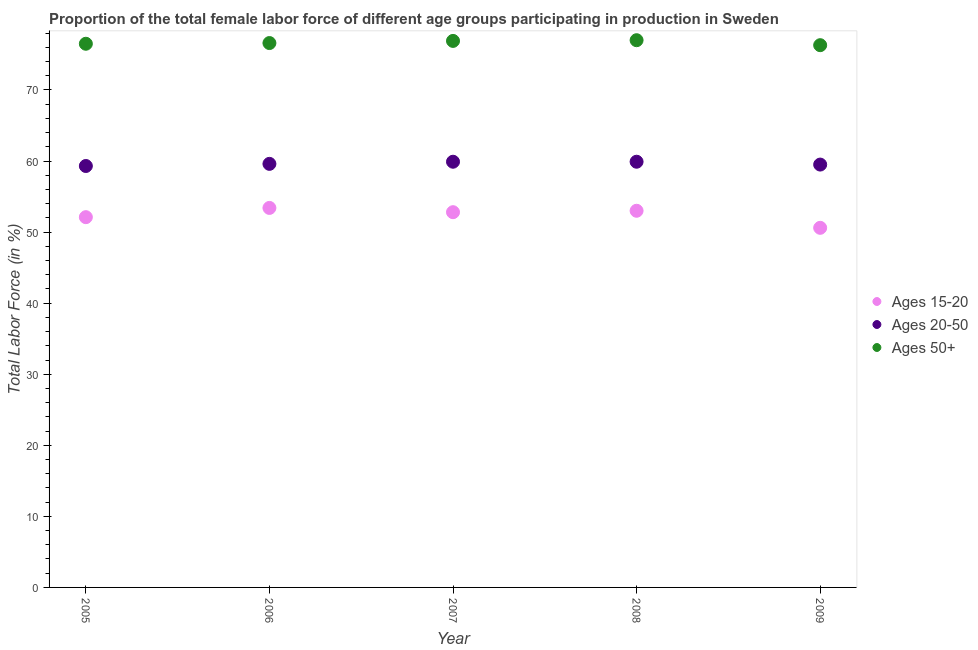How many different coloured dotlines are there?
Make the answer very short. 3. What is the percentage of female labor force above age 50 in 2006?
Ensure brevity in your answer.  76.6. Across all years, what is the maximum percentage of female labor force above age 50?
Offer a terse response. 77. Across all years, what is the minimum percentage of female labor force within the age group 20-50?
Give a very brief answer. 59.3. In which year was the percentage of female labor force above age 50 minimum?
Ensure brevity in your answer.  2009. What is the total percentage of female labor force within the age group 20-50 in the graph?
Offer a terse response. 298.2. What is the difference between the percentage of female labor force within the age group 20-50 in 2008 and that in 2009?
Your response must be concise. 0.4. What is the difference between the percentage of female labor force above age 50 in 2006 and the percentage of female labor force within the age group 15-20 in 2005?
Your response must be concise. 24.5. What is the average percentage of female labor force within the age group 20-50 per year?
Your answer should be very brief. 59.64. In the year 2006, what is the difference between the percentage of female labor force above age 50 and percentage of female labor force within the age group 20-50?
Your answer should be compact. 17. What is the ratio of the percentage of female labor force within the age group 15-20 in 2007 to that in 2008?
Your response must be concise. 1. What is the difference between the highest and the second highest percentage of female labor force within the age group 15-20?
Ensure brevity in your answer.  0.4. What is the difference between the highest and the lowest percentage of female labor force above age 50?
Give a very brief answer. 0.7. In how many years, is the percentage of female labor force within the age group 20-50 greater than the average percentage of female labor force within the age group 20-50 taken over all years?
Ensure brevity in your answer.  2. Is the sum of the percentage of female labor force within the age group 20-50 in 2008 and 2009 greater than the maximum percentage of female labor force above age 50 across all years?
Ensure brevity in your answer.  Yes. Is it the case that in every year, the sum of the percentage of female labor force within the age group 15-20 and percentage of female labor force within the age group 20-50 is greater than the percentage of female labor force above age 50?
Your answer should be very brief. Yes. Does the percentage of female labor force above age 50 monotonically increase over the years?
Provide a short and direct response. No. Is the percentage of female labor force within the age group 15-20 strictly greater than the percentage of female labor force within the age group 20-50 over the years?
Provide a short and direct response. No. Is the percentage of female labor force within the age group 15-20 strictly less than the percentage of female labor force above age 50 over the years?
Give a very brief answer. Yes. How many dotlines are there?
Provide a succinct answer. 3. How many years are there in the graph?
Make the answer very short. 5. What is the difference between two consecutive major ticks on the Y-axis?
Offer a very short reply. 10. Are the values on the major ticks of Y-axis written in scientific E-notation?
Your answer should be compact. No. Does the graph contain any zero values?
Keep it short and to the point. No. Does the graph contain grids?
Provide a short and direct response. No. How are the legend labels stacked?
Offer a very short reply. Vertical. What is the title of the graph?
Offer a terse response. Proportion of the total female labor force of different age groups participating in production in Sweden. Does "Taxes" appear as one of the legend labels in the graph?
Give a very brief answer. No. What is the label or title of the X-axis?
Offer a terse response. Year. What is the label or title of the Y-axis?
Ensure brevity in your answer.  Total Labor Force (in %). What is the Total Labor Force (in %) of Ages 15-20 in 2005?
Your answer should be compact. 52.1. What is the Total Labor Force (in %) of Ages 20-50 in 2005?
Make the answer very short. 59.3. What is the Total Labor Force (in %) of Ages 50+ in 2005?
Give a very brief answer. 76.5. What is the Total Labor Force (in %) in Ages 15-20 in 2006?
Your answer should be very brief. 53.4. What is the Total Labor Force (in %) of Ages 20-50 in 2006?
Offer a terse response. 59.6. What is the Total Labor Force (in %) of Ages 50+ in 2006?
Give a very brief answer. 76.6. What is the Total Labor Force (in %) in Ages 15-20 in 2007?
Provide a short and direct response. 52.8. What is the Total Labor Force (in %) of Ages 20-50 in 2007?
Offer a very short reply. 59.9. What is the Total Labor Force (in %) of Ages 50+ in 2007?
Make the answer very short. 76.9. What is the Total Labor Force (in %) in Ages 15-20 in 2008?
Keep it short and to the point. 53. What is the Total Labor Force (in %) of Ages 20-50 in 2008?
Offer a terse response. 59.9. What is the Total Labor Force (in %) of Ages 15-20 in 2009?
Make the answer very short. 50.6. What is the Total Labor Force (in %) in Ages 20-50 in 2009?
Make the answer very short. 59.5. What is the Total Labor Force (in %) in Ages 50+ in 2009?
Provide a succinct answer. 76.3. Across all years, what is the maximum Total Labor Force (in %) of Ages 15-20?
Provide a short and direct response. 53.4. Across all years, what is the maximum Total Labor Force (in %) of Ages 20-50?
Keep it short and to the point. 59.9. Across all years, what is the minimum Total Labor Force (in %) in Ages 15-20?
Your answer should be compact. 50.6. Across all years, what is the minimum Total Labor Force (in %) of Ages 20-50?
Your answer should be compact. 59.3. Across all years, what is the minimum Total Labor Force (in %) of Ages 50+?
Provide a succinct answer. 76.3. What is the total Total Labor Force (in %) in Ages 15-20 in the graph?
Offer a terse response. 261.9. What is the total Total Labor Force (in %) in Ages 20-50 in the graph?
Keep it short and to the point. 298.2. What is the total Total Labor Force (in %) of Ages 50+ in the graph?
Provide a short and direct response. 383.3. What is the difference between the Total Labor Force (in %) in Ages 15-20 in 2005 and that in 2006?
Provide a succinct answer. -1.3. What is the difference between the Total Labor Force (in %) in Ages 50+ in 2005 and that in 2006?
Provide a short and direct response. -0.1. What is the difference between the Total Labor Force (in %) of Ages 15-20 in 2005 and that in 2008?
Offer a very short reply. -0.9. What is the difference between the Total Labor Force (in %) of Ages 20-50 in 2005 and that in 2008?
Your answer should be compact. -0.6. What is the difference between the Total Labor Force (in %) of Ages 15-20 in 2005 and that in 2009?
Provide a short and direct response. 1.5. What is the difference between the Total Labor Force (in %) of Ages 20-50 in 2005 and that in 2009?
Your response must be concise. -0.2. What is the difference between the Total Labor Force (in %) in Ages 20-50 in 2006 and that in 2007?
Provide a succinct answer. -0.3. What is the difference between the Total Labor Force (in %) in Ages 50+ in 2006 and that in 2007?
Ensure brevity in your answer.  -0.3. What is the difference between the Total Labor Force (in %) of Ages 15-20 in 2006 and that in 2008?
Ensure brevity in your answer.  0.4. What is the difference between the Total Labor Force (in %) in Ages 50+ in 2006 and that in 2009?
Ensure brevity in your answer.  0.3. What is the difference between the Total Labor Force (in %) of Ages 15-20 in 2007 and that in 2008?
Your answer should be very brief. -0.2. What is the difference between the Total Labor Force (in %) of Ages 20-50 in 2007 and that in 2008?
Offer a terse response. 0. What is the difference between the Total Labor Force (in %) in Ages 50+ in 2007 and that in 2008?
Make the answer very short. -0.1. What is the difference between the Total Labor Force (in %) in Ages 20-50 in 2007 and that in 2009?
Your answer should be compact. 0.4. What is the difference between the Total Labor Force (in %) in Ages 50+ in 2007 and that in 2009?
Give a very brief answer. 0.6. What is the difference between the Total Labor Force (in %) of Ages 50+ in 2008 and that in 2009?
Give a very brief answer. 0.7. What is the difference between the Total Labor Force (in %) of Ages 15-20 in 2005 and the Total Labor Force (in %) of Ages 20-50 in 2006?
Give a very brief answer. -7.5. What is the difference between the Total Labor Force (in %) of Ages 15-20 in 2005 and the Total Labor Force (in %) of Ages 50+ in 2006?
Make the answer very short. -24.5. What is the difference between the Total Labor Force (in %) of Ages 20-50 in 2005 and the Total Labor Force (in %) of Ages 50+ in 2006?
Your answer should be compact. -17.3. What is the difference between the Total Labor Force (in %) in Ages 15-20 in 2005 and the Total Labor Force (in %) in Ages 50+ in 2007?
Your answer should be very brief. -24.8. What is the difference between the Total Labor Force (in %) in Ages 20-50 in 2005 and the Total Labor Force (in %) in Ages 50+ in 2007?
Your response must be concise. -17.6. What is the difference between the Total Labor Force (in %) of Ages 15-20 in 2005 and the Total Labor Force (in %) of Ages 50+ in 2008?
Offer a very short reply. -24.9. What is the difference between the Total Labor Force (in %) of Ages 20-50 in 2005 and the Total Labor Force (in %) of Ages 50+ in 2008?
Offer a very short reply. -17.7. What is the difference between the Total Labor Force (in %) of Ages 15-20 in 2005 and the Total Labor Force (in %) of Ages 20-50 in 2009?
Give a very brief answer. -7.4. What is the difference between the Total Labor Force (in %) of Ages 15-20 in 2005 and the Total Labor Force (in %) of Ages 50+ in 2009?
Make the answer very short. -24.2. What is the difference between the Total Labor Force (in %) in Ages 15-20 in 2006 and the Total Labor Force (in %) in Ages 20-50 in 2007?
Offer a very short reply. -6.5. What is the difference between the Total Labor Force (in %) in Ages 15-20 in 2006 and the Total Labor Force (in %) in Ages 50+ in 2007?
Your answer should be compact. -23.5. What is the difference between the Total Labor Force (in %) in Ages 20-50 in 2006 and the Total Labor Force (in %) in Ages 50+ in 2007?
Your response must be concise. -17.3. What is the difference between the Total Labor Force (in %) in Ages 15-20 in 2006 and the Total Labor Force (in %) in Ages 50+ in 2008?
Provide a succinct answer. -23.6. What is the difference between the Total Labor Force (in %) of Ages 20-50 in 2006 and the Total Labor Force (in %) of Ages 50+ in 2008?
Your answer should be compact. -17.4. What is the difference between the Total Labor Force (in %) in Ages 15-20 in 2006 and the Total Labor Force (in %) in Ages 20-50 in 2009?
Provide a succinct answer. -6.1. What is the difference between the Total Labor Force (in %) of Ages 15-20 in 2006 and the Total Labor Force (in %) of Ages 50+ in 2009?
Your response must be concise. -22.9. What is the difference between the Total Labor Force (in %) of Ages 20-50 in 2006 and the Total Labor Force (in %) of Ages 50+ in 2009?
Your answer should be compact. -16.7. What is the difference between the Total Labor Force (in %) in Ages 15-20 in 2007 and the Total Labor Force (in %) in Ages 20-50 in 2008?
Give a very brief answer. -7.1. What is the difference between the Total Labor Force (in %) in Ages 15-20 in 2007 and the Total Labor Force (in %) in Ages 50+ in 2008?
Offer a terse response. -24.2. What is the difference between the Total Labor Force (in %) of Ages 20-50 in 2007 and the Total Labor Force (in %) of Ages 50+ in 2008?
Ensure brevity in your answer.  -17.1. What is the difference between the Total Labor Force (in %) of Ages 15-20 in 2007 and the Total Labor Force (in %) of Ages 50+ in 2009?
Your response must be concise. -23.5. What is the difference between the Total Labor Force (in %) in Ages 20-50 in 2007 and the Total Labor Force (in %) in Ages 50+ in 2009?
Your answer should be very brief. -16.4. What is the difference between the Total Labor Force (in %) of Ages 15-20 in 2008 and the Total Labor Force (in %) of Ages 20-50 in 2009?
Your response must be concise. -6.5. What is the difference between the Total Labor Force (in %) in Ages 15-20 in 2008 and the Total Labor Force (in %) in Ages 50+ in 2009?
Your response must be concise. -23.3. What is the difference between the Total Labor Force (in %) in Ages 20-50 in 2008 and the Total Labor Force (in %) in Ages 50+ in 2009?
Your answer should be very brief. -16.4. What is the average Total Labor Force (in %) of Ages 15-20 per year?
Keep it short and to the point. 52.38. What is the average Total Labor Force (in %) of Ages 20-50 per year?
Give a very brief answer. 59.64. What is the average Total Labor Force (in %) of Ages 50+ per year?
Offer a very short reply. 76.66. In the year 2005, what is the difference between the Total Labor Force (in %) in Ages 15-20 and Total Labor Force (in %) in Ages 50+?
Provide a short and direct response. -24.4. In the year 2005, what is the difference between the Total Labor Force (in %) of Ages 20-50 and Total Labor Force (in %) of Ages 50+?
Offer a very short reply. -17.2. In the year 2006, what is the difference between the Total Labor Force (in %) of Ages 15-20 and Total Labor Force (in %) of Ages 20-50?
Your answer should be compact. -6.2. In the year 2006, what is the difference between the Total Labor Force (in %) of Ages 15-20 and Total Labor Force (in %) of Ages 50+?
Keep it short and to the point. -23.2. In the year 2007, what is the difference between the Total Labor Force (in %) in Ages 15-20 and Total Labor Force (in %) in Ages 50+?
Offer a very short reply. -24.1. In the year 2008, what is the difference between the Total Labor Force (in %) in Ages 15-20 and Total Labor Force (in %) in Ages 20-50?
Provide a succinct answer. -6.9. In the year 2008, what is the difference between the Total Labor Force (in %) of Ages 15-20 and Total Labor Force (in %) of Ages 50+?
Your response must be concise. -24. In the year 2008, what is the difference between the Total Labor Force (in %) in Ages 20-50 and Total Labor Force (in %) in Ages 50+?
Your answer should be compact. -17.1. In the year 2009, what is the difference between the Total Labor Force (in %) in Ages 15-20 and Total Labor Force (in %) in Ages 20-50?
Your answer should be compact. -8.9. In the year 2009, what is the difference between the Total Labor Force (in %) of Ages 15-20 and Total Labor Force (in %) of Ages 50+?
Provide a succinct answer. -25.7. In the year 2009, what is the difference between the Total Labor Force (in %) of Ages 20-50 and Total Labor Force (in %) of Ages 50+?
Your answer should be very brief. -16.8. What is the ratio of the Total Labor Force (in %) in Ages 15-20 in 2005 to that in 2006?
Your answer should be compact. 0.98. What is the ratio of the Total Labor Force (in %) of Ages 20-50 in 2005 to that in 2006?
Make the answer very short. 0.99. What is the ratio of the Total Labor Force (in %) of Ages 50+ in 2005 to that in 2006?
Provide a succinct answer. 1. What is the ratio of the Total Labor Force (in %) in Ages 15-20 in 2005 to that in 2007?
Keep it short and to the point. 0.99. What is the ratio of the Total Labor Force (in %) in Ages 50+ in 2005 to that in 2008?
Provide a short and direct response. 0.99. What is the ratio of the Total Labor Force (in %) in Ages 15-20 in 2005 to that in 2009?
Make the answer very short. 1.03. What is the ratio of the Total Labor Force (in %) in Ages 20-50 in 2005 to that in 2009?
Ensure brevity in your answer.  1. What is the ratio of the Total Labor Force (in %) in Ages 50+ in 2005 to that in 2009?
Offer a terse response. 1. What is the ratio of the Total Labor Force (in %) of Ages 15-20 in 2006 to that in 2007?
Provide a short and direct response. 1.01. What is the ratio of the Total Labor Force (in %) of Ages 20-50 in 2006 to that in 2007?
Provide a short and direct response. 0.99. What is the ratio of the Total Labor Force (in %) of Ages 15-20 in 2006 to that in 2008?
Keep it short and to the point. 1.01. What is the ratio of the Total Labor Force (in %) in Ages 20-50 in 2006 to that in 2008?
Ensure brevity in your answer.  0.99. What is the ratio of the Total Labor Force (in %) of Ages 50+ in 2006 to that in 2008?
Make the answer very short. 0.99. What is the ratio of the Total Labor Force (in %) of Ages 15-20 in 2006 to that in 2009?
Provide a short and direct response. 1.06. What is the ratio of the Total Labor Force (in %) of Ages 20-50 in 2006 to that in 2009?
Offer a terse response. 1. What is the ratio of the Total Labor Force (in %) of Ages 15-20 in 2007 to that in 2008?
Offer a terse response. 1. What is the ratio of the Total Labor Force (in %) of Ages 20-50 in 2007 to that in 2008?
Your answer should be very brief. 1. What is the ratio of the Total Labor Force (in %) in Ages 50+ in 2007 to that in 2008?
Provide a succinct answer. 1. What is the ratio of the Total Labor Force (in %) of Ages 15-20 in 2007 to that in 2009?
Provide a short and direct response. 1.04. What is the ratio of the Total Labor Force (in %) of Ages 20-50 in 2007 to that in 2009?
Your answer should be very brief. 1.01. What is the ratio of the Total Labor Force (in %) of Ages 50+ in 2007 to that in 2009?
Offer a terse response. 1.01. What is the ratio of the Total Labor Force (in %) of Ages 15-20 in 2008 to that in 2009?
Provide a succinct answer. 1.05. What is the ratio of the Total Labor Force (in %) in Ages 20-50 in 2008 to that in 2009?
Your response must be concise. 1.01. What is the ratio of the Total Labor Force (in %) of Ages 50+ in 2008 to that in 2009?
Provide a succinct answer. 1.01. What is the difference between the highest and the second highest Total Labor Force (in %) in Ages 50+?
Provide a succinct answer. 0.1. 